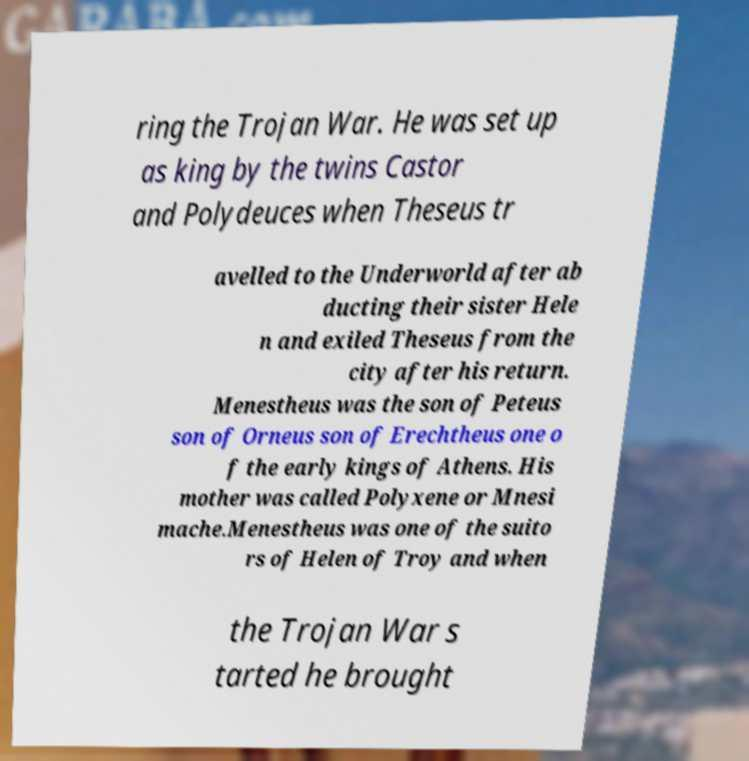Please identify and transcribe the text found in this image. ring the Trojan War. He was set up as king by the twins Castor and Polydeuces when Theseus tr avelled to the Underworld after ab ducting their sister Hele n and exiled Theseus from the city after his return. Menestheus was the son of Peteus son of Orneus son of Erechtheus one o f the early kings of Athens. His mother was called Polyxene or Mnesi mache.Menestheus was one of the suito rs of Helen of Troy and when the Trojan War s tarted he brought 